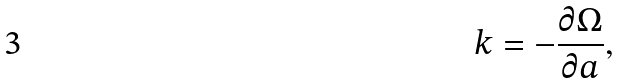Convert formula to latex. <formula><loc_0><loc_0><loc_500><loc_500>k = - \frac { \partial \Omega } { \partial a } ,</formula> 